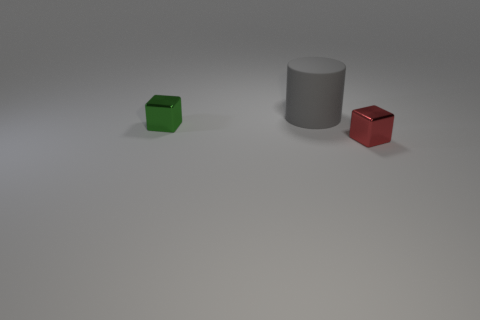Add 3 brown metallic cubes. How many objects exist? 6 Subtract all cubes. How many objects are left? 1 Subtract all blue blocks. Subtract all blue cylinders. How many blocks are left? 2 Subtract all tiny red metallic cubes. Subtract all matte objects. How many objects are left? 1 Add 1 small shiny cubes. How many small shiny cubes are left? 3 Add 3 shiny blocks. How many shiny blocks exist? 5 Subtract all red blocks. How many blocks are left? 1 Subtract 0 purple blocks. How many objects are left? 3 